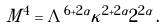Convert formula to latex. <formula><loc_0><loc_0><loc_500><loc_500>M ^ { 4 } = \Lambda ^ { 6 + 2 \alpha } \kappa ^ { 2 + 2 \alpha } 2 ^ { 2 \alpha } \, .</formula> 